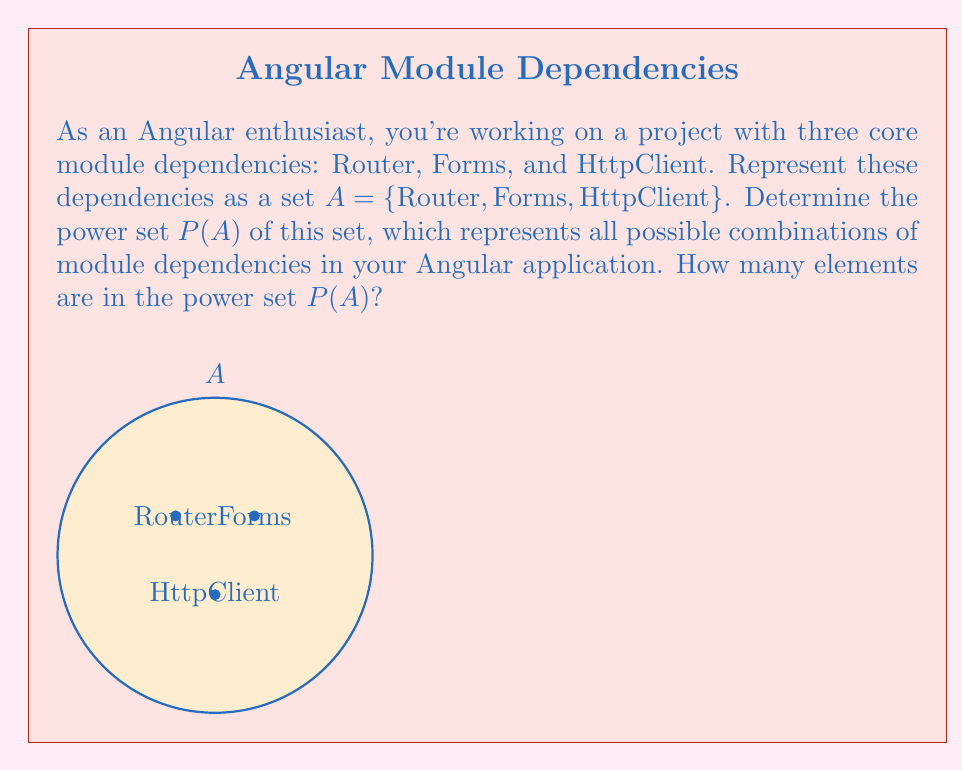Provide a solution to this math problem. Let's approach this step-by-step:

1) First, recall that the power set of a set A is the set of all subsets of A, including the empty set and A itself.

2) For a set with n elements, the number of elements in its power set is $2^n$.

3) In our case, set A has 3 elements: Router, Forms, and HttpClient.

4) Therefore, the number of elements in P(A) will be $2^3 = 8$.

5) Let's list all the elements of P(A):

   - $\emptyset$ (empty set)
   - {Router}
   - {Forms}
   - {HttpClient}
   - {Router, Forms}
   - {Router, HttpClient}
   - {Forms, HttpClient}
   - {Router, Forms, HttpClient}

6) Each element in P(A) represents a possible combination of module dependencies in your Angular application, from using no modules (empty set) to using all three modules.

7) The power set P(A) is the set containing all these subsets:

   P(A) = {$\emptyset$, {Router}, {Forms}, {HttpClient}, {Router, Forms}, {Router, HttpClient}, {Forms, HttpClient}, {Router, Forms, HttpClient}}

8) Counting these elements confirms that there are indeed 8 elements in P(A).
Answer: $|P(A)| = 2^3 = 8$ 